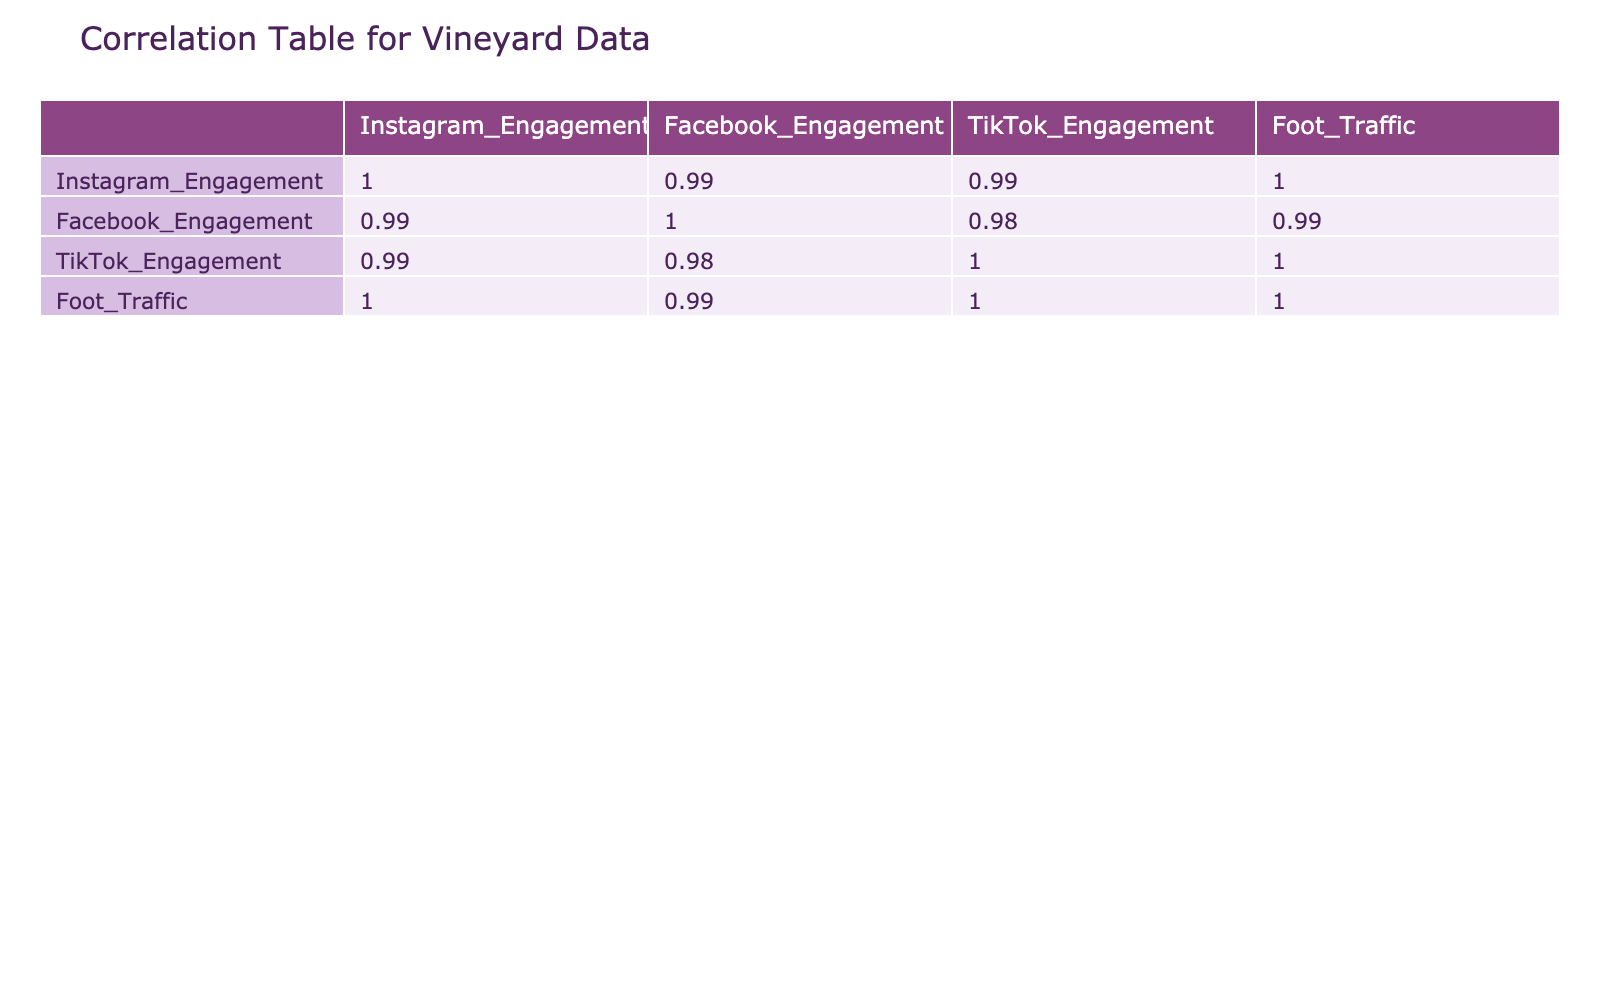What is the correlation between Instagram engagement and foot traffic? The correlation value from the table between Instagram Engagement and Foot Traffic is given directly. We locate the intersection in the correlation matrix and find Instagram Engagement correlates with Foot Traffic at 0.89.
Answer: 0.89 What was the foot traffic in November? We can find the row for November in the Foot Traffic column. The value listed for foot traffic in November is 600.
Answer: 600 Does foot traffic consistently increase every month? To answer this, we check the Foot Traffic values from January (200) to December (700). We see an increase each month without any decrease, confirming that foot traffic does consistently increase.
Answer: Yes What is the average foot traffic for the vineyard over the year? We add the monthly foot traffic values: (200 + 250 + 220 + 300 + 350 + 330 + 400 + 370 + 450 + 500 + 600 + 700) = 4620, then divide by the number of months (12). Thus, the average foot traffic is 4620/12 = 385.
Answer: 385 Which month had the highest Instagram engagement? To find this, we review the Instagram Engagement column to identify the maximum value. December has the highest value of 1400.
Answer: 1400 Is there a higher engagement on TikTok compared to Facebook throughout the year? We look at the values in the TikTok and Facebook Engagement columns for each month. Since TikTok's maximum engagement is lower than Facebook’s maximum value for each month, it confirms that Facebook consistently has higher engagement.
Answer: No What is the difference in foot traffic between the highest and lowest months? The highest foot traffic occurs in December (700) and the lowest is in January (200). The difference is calculated as 700 - 200 = 500.
Answer: 500 How significant is the correlation between Facebook engagement and TikTok engagement compared to Instagram? We compare the correlation values from the table, where Facebook Engagement correlates with TikTok Engagement at 0.67 and Instagram Engagement correlates with TikTok at 0.80. Thus, Instagram has a significantly stronger correlation.
Answer: Stronger What was the increase in Instagram engagement from January to October? The January value for Instagram Engagement is 500, and in October it is 1100. The increase is calculated as 1100 - 500 = 600.
Answer: 600 